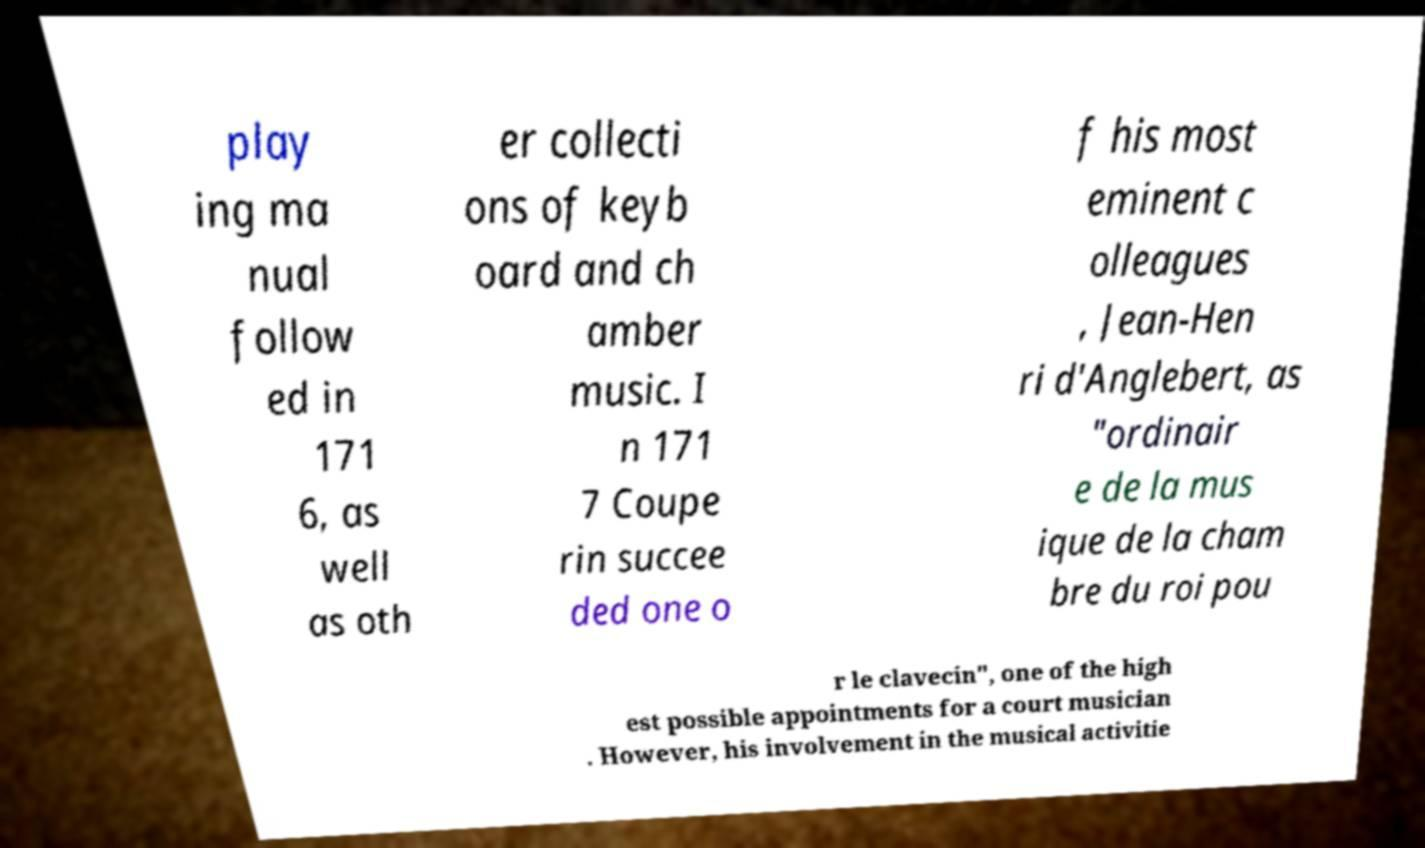Please read and relay the text visible in this image. What does it say? play ing ma nual follow ed in 171 6, as well as oth er collecti ons of keyb oard and ch amber music. I n 171 7 Coupe rin succee ded one o f his most eminent c olleagues , Jean-Hen ri d'Anglebert, as "ordinair e de la mus ique de la cham bre du roi pou r le clavecin", one of the high est possible appointments for a court musician . However, his involvement in the musical activitie 